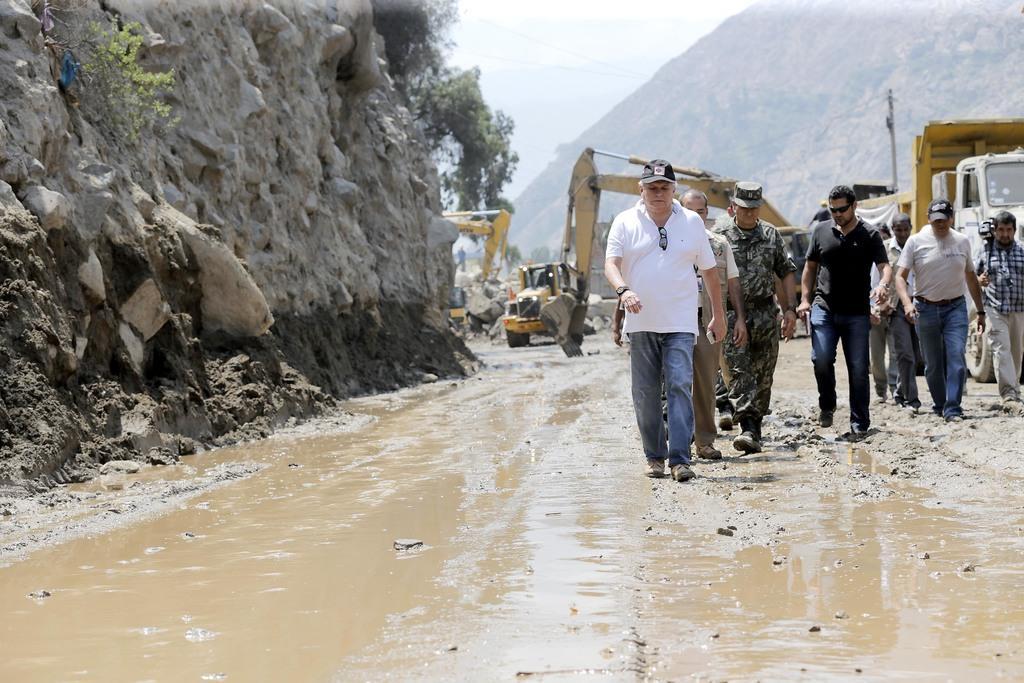How would you summarize this image in a sentence or two? In this image there is the sky truncated towards the top of the image, there is a mountain truncated towards the top of the image, there is a pole, there are wires, there are vehicles on the road, there is a vehicle truncated towards the right of the image, there are group of person walking on the road, there are persons holding objects, there is a person truncated towards the right of the image, there is water on the road, there is a mountain truncated towards the left of the image, there are plants, there are rocks. 